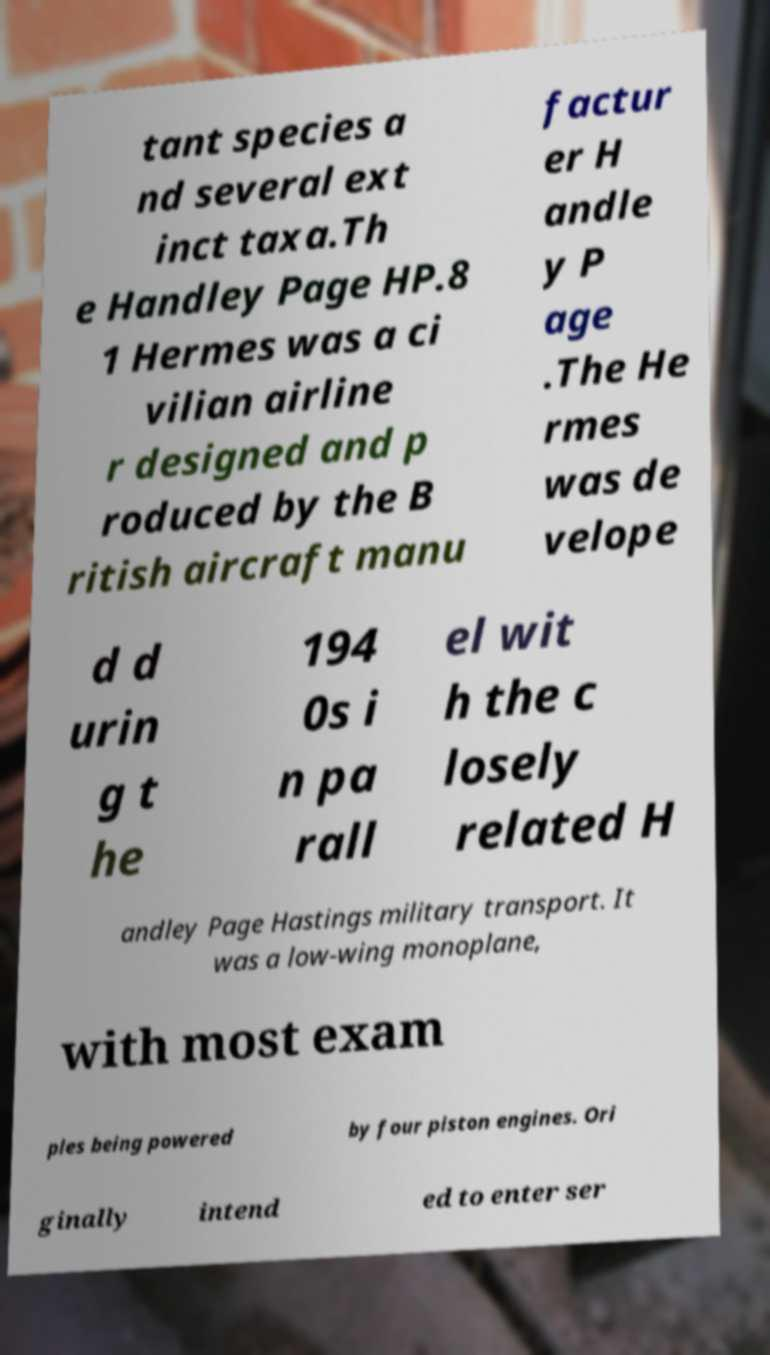Could you extract and type out the text from this image? tant species a nd several ext inct taxa.Th e Handley Page HP.8 1 Hermes was a ci vilian airline r designed and p roduced by the B ritish aircraft manu factur er H andle y P age .The He rmes was de velope d d urin g t he 194 0s i n pa rall el wit h the c losely related H andley Page Hastings military transport. It was a low-wing monoplane, with most exam ples being powered by four piston engines. Ori ginally intend ed to enter ser 